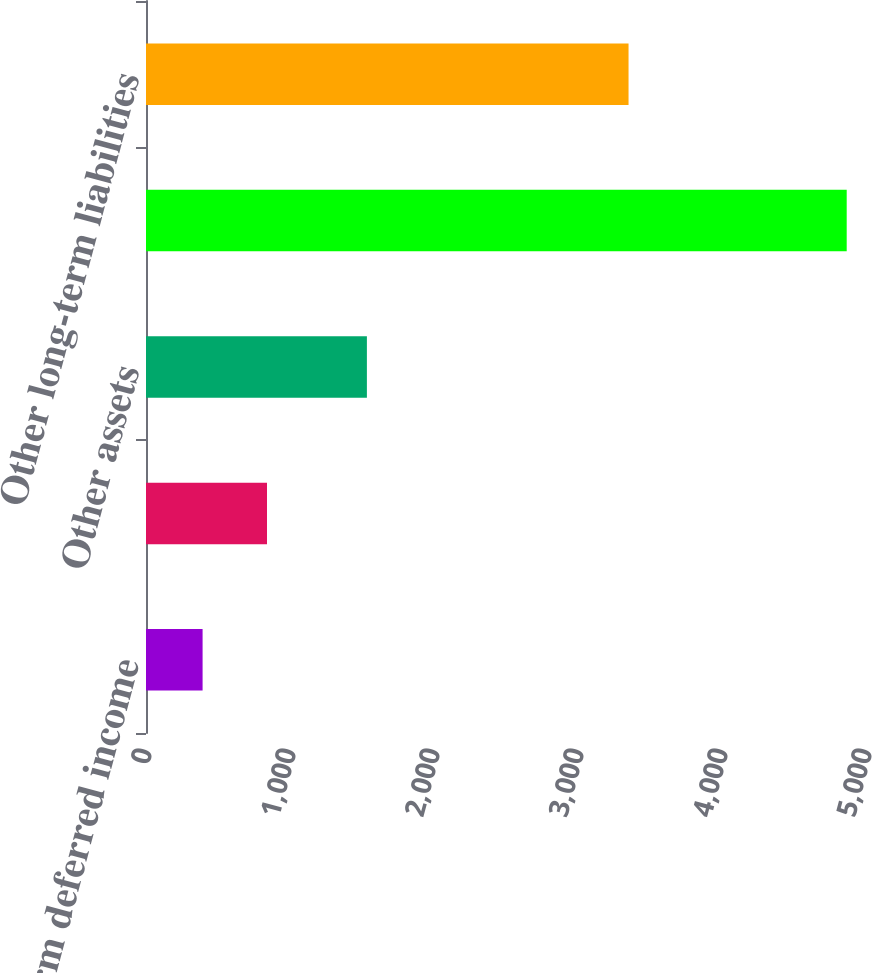Convert chart to OTSL. <chart><loc_0><loc_0><loc_500><loc_500><bar_chart><fcel>Short-term deferred income<fcel>Prepaid expense and other<fcel>Other assets<fcel>Accounts payable and accrued<fcel>Other long-term liabilities<nl><fcel>393<fcel>840.3<fcel>1534<fcel>4866<fcel>3351<nl></chart> 